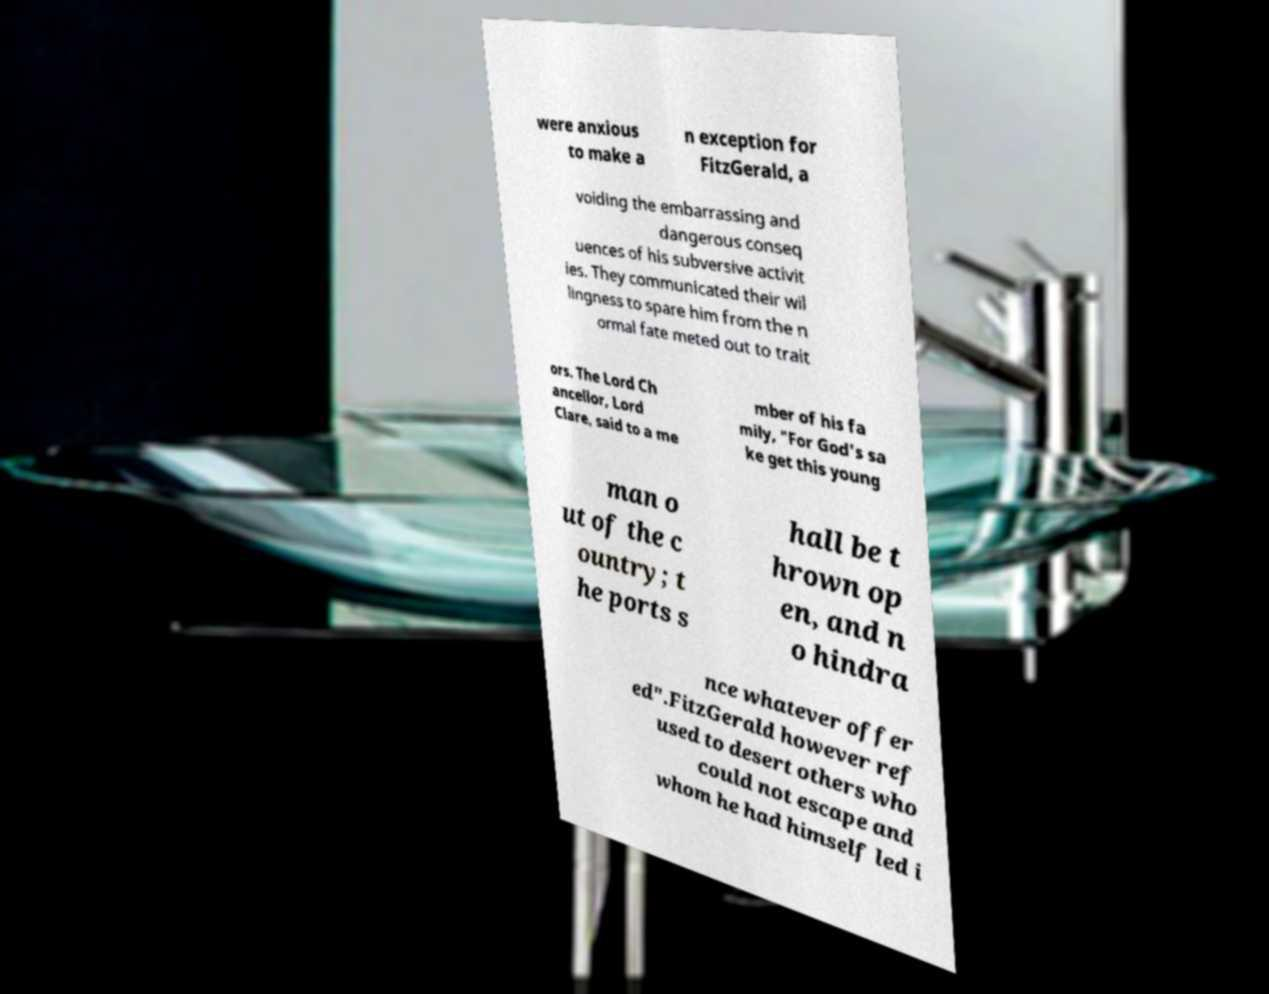Please identify and transcribe the text found in this image. were anxious to make a n exception for FitzGerald, a voiding the embarrassing and dangerous conseq uences of his subversive activit ies. They communicated their wil lingness to spare him from the n ormal fate meted out to trait ors. The Lord Ch ancellor, Lord Clare, said to a me mber of his fa mily, "For God's sa ke get this young man o ut of the c ountry; t he ports s hall be t hrown op en, and n o hindra nce whatever offer ed".FitzGerald however ref used to desert others who could not escape and whom he had himself led i 